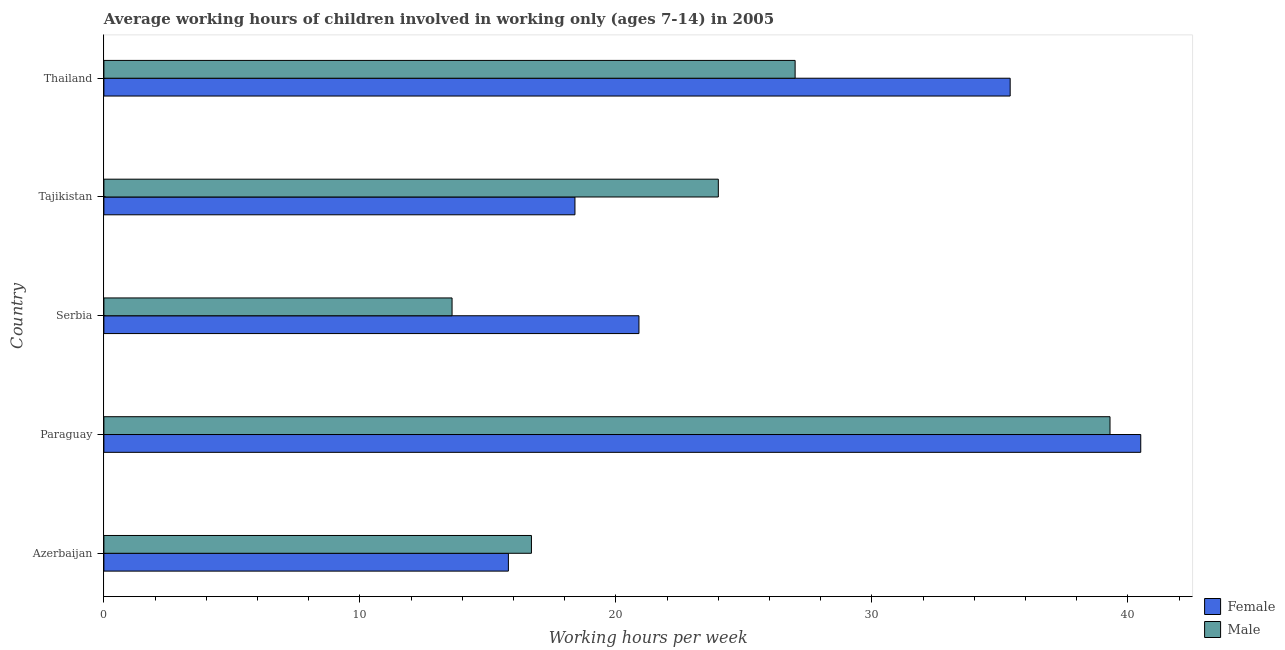How many groups of bars are there?
Your answer should be compact. 5. Are the number of bars per tick equal to the number of legend labels?
Ensure brevity in your answer.  Yes. How many bars are there on the 2nd tick from the top?
Make the answer very short. 2. What is the label of the 4th group of bars from the top?
Give a very brief answer. Paraguay. What is the average working hour of female children in Tajikistan?
Give a very brief answer. 18.4. Across all countries, what is the maximum average working hour of female children?
Offer a terse response. 40.5. Across all countries, what is the minimum average working hour of male children?
Give a very brief answer. 13.6. In which country was the average working hour of female children maximum?
Offer a very short reply. Paraguay. In which country was the average working hour of male children minimum?
Your response must be concise. Serbia. What is the total average working hour of female children in the graph?
Keep it short and to the point. 131. What is the difference between the average working hour of female children in Serbia and the average working hour of male children in Tajikistan?
Your answer should be very brief. -3.1. What is the average average working hour of male children per country?
Offer a terse response. 24.12. In how many countries, is the average working hour of female children greater than 36 hours?
Offer a terse response. 1. What is the ratio of the average working hour of male children in Tajikistan to that in Thailand?
Your response must be concise. 0.89. Is the average working hour of male children in Azerbaijan less than that in Tajikistan?
Your answer should be compact. Yes. Is the difference between the average working hour of male children in Serbia and Thailand greater than the difference between the average working hour of female children in Serbia and Thailand?
Provide a succinct answer. Yes. What is the difference between the highest and the second highest average working hour of female children?
Offer a terse response. 5.1. What is the difference between the highest and the lowest average working hour of male children?
Keep it short and to the point. 25.7. Is the sum of the average working hour of male children in Azerbaijan and Tajikistan greater than the maximum average working hour of female children across all countries?
Provide a short and direct response. Yes. What does the 2nd bar from the top in Paraguay represents?
Your answer should be very brief. Female. What does the 1st bar from the bottom in Azerbaijan represents?
Your answer should be very brief. Female. How many bars are there?
Keep it short and to the point. 10. How many countries are there in the graph?
Offer a terse response. 5. What is the difference between two consecutive major ticks on the X-axis?
Offer a very short reply. 10. How many legend labels are there?
Offer a terse response. 2. How are the legend labels stacked?
Give a very brief answer. Vertical. What is the title of the graph?
Provide a succinct answer. Average working hours of children involved in working only (ages 7-14) in 2005. Does "Food" appear as one of the legend labels in the graph?
Make the answer very short. No. What is the label or title of the X-axis?
Provide a short and direct response. Working hours per week. What is the label or title of the Y-axis?
Your answer should be compact. Country. What is the Working hours per week in Female in Azerbaijan?
Ensure brevity in your answer.  15.8. What is the Working hours per week of Female in Paraguay?
Offer a very short reply. 40.5. What is the Working hours per week in Male in Paraguay?
Provide a succinct answer. 39.3. What is the Working hours per week of Female in Serbia?
Give a very brief answer. 20.9. What is the Working hours per week of Male in Serbia?
Offer a very short reply. 13.6. What is the Working hours per week of Female in Tajikistan?
Provide a short and direct response. 18.4. What is the Working hours per week of Male in Tajikistan?
Offer a very short reply. 24. What is the Working hours per week of Female in Thailand?
Offer a terse response. 35.4. Across all countries, what is the maximum Working hours per week of Female?
Your answer should be very brief. 40.5. Across all countries, what is the maximum Working hours per week in Male?
Provide a succinct answer. 39.3. Across all countries, what is the minimum Working hours per week of Male?
Keep it short and to the point. 13.6. What is the total Working hours per week of Female in the graph?
Make the answer very short. 131. What is the total Working hours per week of Male in the graph?
Offer a very short reply. 120.6. What is the difference between the Working hours per week in Female in Azerbaijan and that in Paraguay?
Give a very brief answer. -24.7. What is the difference between the Working hours per week in Male in Azerbaijan and that in Paraguay?
Your response must be concise. -22.6. What is the difference between the Working hours per week of Female in Azerbaijan and that in Serbia?
Ensure brevity in your answer.  -5.1. What is the difference between the Working hours per week in Male in Azerbaijan and that in Serbia?
Your response must be concise. 3.1. What is the difference between the Working hours per week in Female in Azerbaijan and that in Tajikistan?
Provide a succinct answer. -2.6. What is the difference between the Working hours per week of Female in Azerbaijan and that in Thailand?
Provide a succinct answer. -19.6. What is the difference between the Working hours per week of Female in Paraguay and that in Serbia?
Ensure brevity in your answer.  19.6. What is the difference between the Working hours per week of Male in Paraguay and that in Serbia?
Give a very brief answer. 25.7. What is the difference between the Working hours per week in Female in Paraguay and that in Tajikistan?
Your response must be concise. 22.1. What is the difference between the Working hours per week of Male in Paraguay and that in Tajikistan?
Offer a very short reply. 15.3. What is the difference between the Working hours per week of Female in Paraguay and that in Thailand?
Offer a very short reply. 5.1. What is the difference between the Working hours per week of Male in Paraguay and that in Thailand?
Provide a succinct answer. 12.3. What is the difference between the Working hours per week in Male in Serbia and that in Tajikistan?
Keep it short and to the point. -10.4. What is the difference between the Working hours per week in Male in Tajikistan and that in Thailand?
Ensure brevity in your answer.  -3. What is the difference between the Working hours per week in Female in Azerbaijan and the Working hours per week in Male in Paraguay?
Offer a terse response. -23.5. What is the difference between the Working hours per week in Female in Azerbaijan and the Working hours per week in Male in Serbia?
Keep it short and to the point. 2.2. What is the difference between the Working hours per week of Female in Azerbaijan and the Working hours per week of Male in Thailand?
Offer a very short reply. -11.2. What is the difference between the Working hours per week in Female in Paraguay and the Working hours per week in Male in Serbia?
Provide a short and direct response. 26.9. What is the difference between the Working hours per week of Female in Paraguay and the Working hours per week of Male in Tajikistan?
Your answer should be very brief. 16.5. What is the difference between the Working hours per week of Female in Paraguay and the Working hours per week of Male in Thailand?
Ensure brevity in your answer.  13.5. What is the average Working hours per week in Female per country?
Provide a short and direct response. 26.2. What is the average Working hours per week of Male per country?
Your answer should be very brief. 24.12. What is the difference between the Working hours per week of Female and Working hours per week of Male in Azerbaijan?
Keep it short and to the point. -0.9. What is the difference between the Working hours per week in Female and Working hours per week in Male in Serbia?
Your answer should be compact. 7.3. What is the ratio of the Working hours per week in Female in Azerbaijan to that in Paraguay?
Keep it short and to the point. 0.39. What is the ratio of the Working hours per week in Male in Azerbaijan to that in Paraguay?
Your response must be concise. 0.42. What is the ratio of the Working hours per week of Female in Azerbaijan to that in Serbia?
Keep it short and to the point. 0.76. What is the ratio of the Working hours per week in Male in Azerbaijan to that in Serbia?
Give a very brief answer. 1.23. What is the ratio of the Working hours per week in Female in Azerbaijan to that in Tajikistan?
Your answer should be very brief. 0.86. What is the ratio of the Working hours per week in Male in Azerbaijan to that in Tajikistan?
Your answer should be compact. 0.7. What is the ratio of the Working hours per week of Female in Azerbaijan to that in Thailand?
Offer a terse response. 0.45. What is the ratio of the Working hours per week in Male in Azerbaijan to that in Thailand?
Your answer should be compact. 0.62. What is the ratio of the Working hours per week of Female in Paraguay to that in Serbia?
Ensure brevity in your answer.  1.94. What is the ratio of the Working hours per week of Male in Paraguay to that in Serbia?
Offer a terse response. 2.89. What is the ratio of the Working hours per week in Female in Paraguay to that in Tajikistan?
Your response must be concise. 2.2. What is the ratio of the Working hours per week in Male in Paraguay to that in Tajikistan?
Provide a succinct answer. 1.64. What is the ratio of the Working hours per week in Female in Paraguay to that in Thailand?
Make the answer very short. 1.14. What is the ratio of the Working hours per week in Male in Paraguay to that in Thailand?
Your response must be concise. 1.46. What is the ratio of the Working hours per week of Female in Serbia to that in Tajikistan?
Ensure brevity in your answer.  1.14. What is the ratio of the Working hours per week in Male in Serbia to that in Tajikistan?
Offer a very short reply. 0.57. What is the ratio of the Working hours per week in Female in Serbia to that in Thailand?
Your answer should be compact. 0.59. What is the ratio of the Working hours per week of Male in Serbia to that in Thailand?
Keep it short and to the point. 0.5. What is the ratio of the Working hours per week of Female in Tajikistan to that in Thailand?
Your response must be concise. 0.52. What is the ratio of the Working hours per week of Male in Tajikistan to that in Thailand?
Keep it short and to the point. 0.89. What is the difference between the highest and the second highest Working hours per week in Female?
Your answer should be compact. 5.1. What is the difference between the highest and the lowest Working hours per week of Female?
Your response must be concise. 24.7. What is the difference between the highest and the lowest Working hours per week of Male?
Your response must be concise. 25.7. 